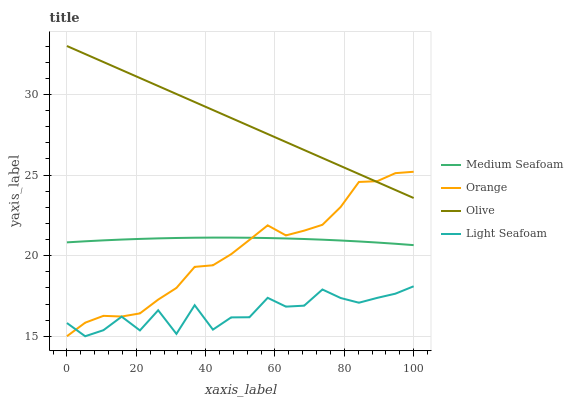Does Light Seafoam have the minimum area under the curve?
Answer yes or no. Yes. Does Olive have the maximum area under the curve?
Answer yes or no. Yes. Does Olive have the minimum area under the curve?
Answer yes or no. No. Does Light Seafoam have the maximum area under the curve?
Answer yes or no. No. Is Olive the smoothest?
Answer yes or no. Yes. Is Light Seafoam the roughest?
Answer yes or no. Yes. Is Light Seafoam the smoothest?
Answer yes or no. No. Is Olive the roughest?
Answer yes or no. No. Does Olive have the lowest value?
Answer yes or no. No. Does Olive have the highest value?
Answer yes or no. Yes. Does Light Seafoam have the highest value?
Answer yes or no. No. Is Light Seafoam less than Olive?
Answer yes or no. Yes. Is Medium Seafoam greater than Light Seafoam?
Answer yes or no. Yes. Does Light Seafoam intersect Olive?
Answer yes or no. No. 